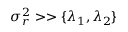Convert formula to latex. <formula><loc_0><loc_0><loc_500><loc_500>\sigma _ { r } ^ { 2 } > > \{ \lambda _ { 1 } , \lambda _ { 2 } \}</formula> 